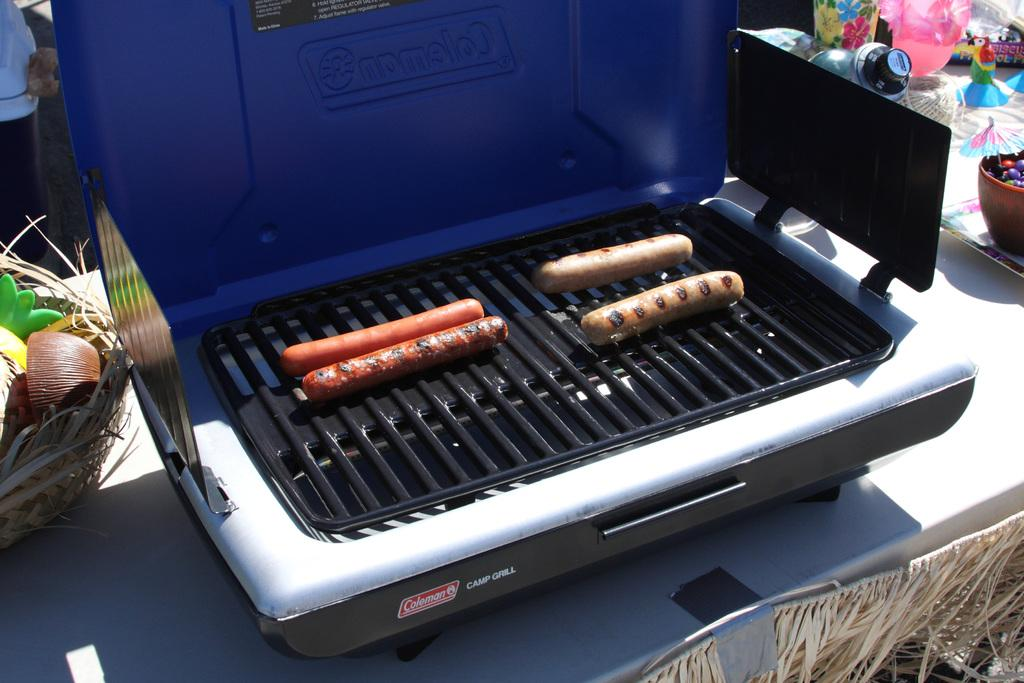<image>
Describe the image concisely. Four hotdogs sitting on a Coleman camp grill 